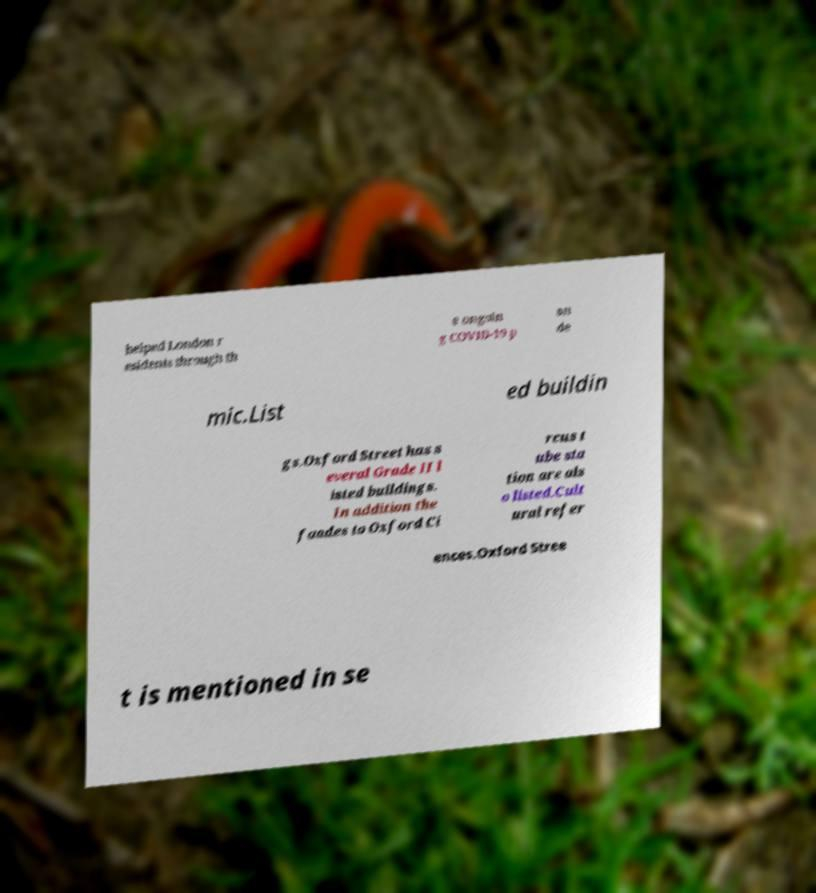Please read and relay the text visible in this image. What does it say? helped London r esidents through th e ongoin g COVID-19 p an de mic.List ed buildin gs.Oxford Street has s everal Grade II l isted buildings. In addition the faades to Oxford Ci rcus t ube sta tion are als o listed.Cult ural refer ences.Oxford Stree t is mentioned in se 